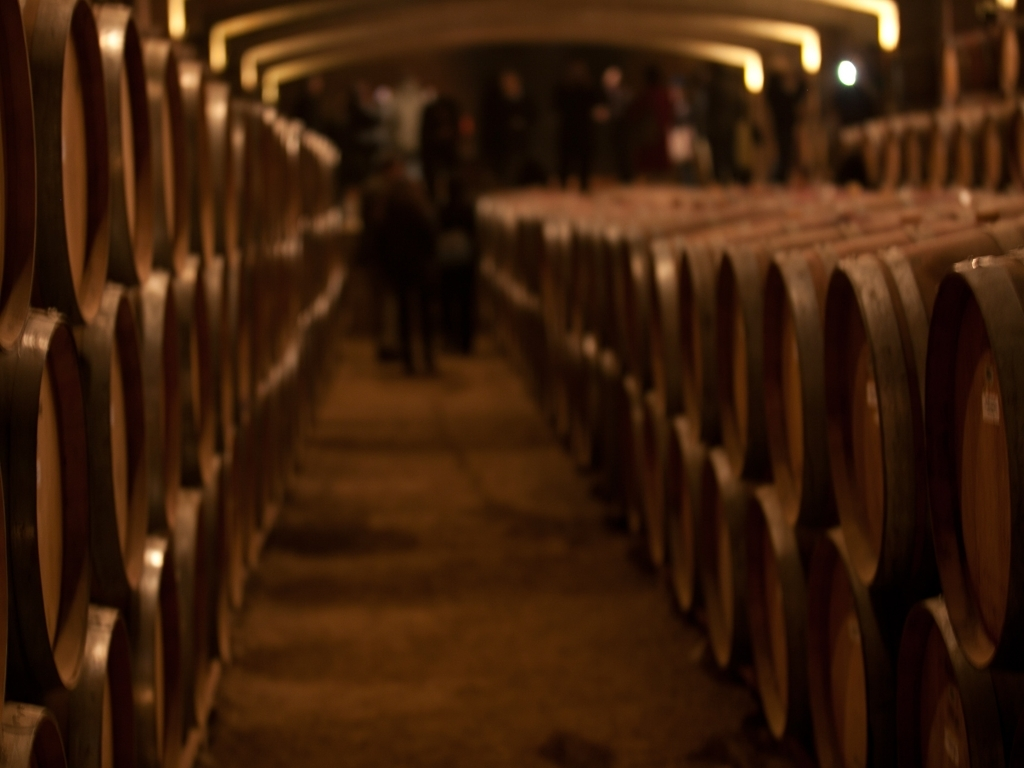Can you tell me what is being stored in these barrels? The image depicts a collection of wooden barrels typically used for aging wine or spirits, such as whiskey. The process of aging in barrels allows for the development of complex flavors and aromas in the beverage. 